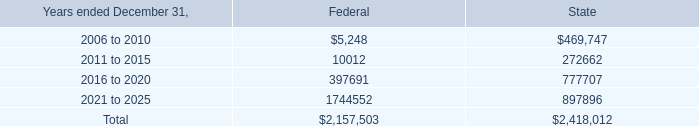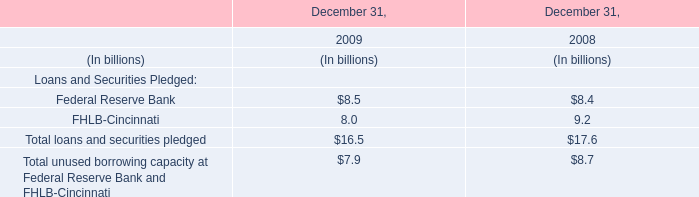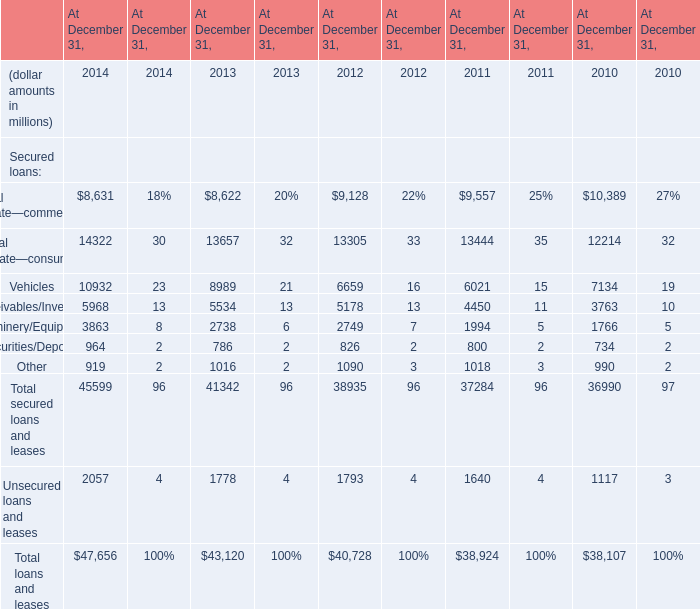What is the sum of 2016 to 2020 of State, and Receivables/Inventory of At December 31, 2010 ? 
Computations: (777707.0 + 3763.0)
Answer: 781470.0. 